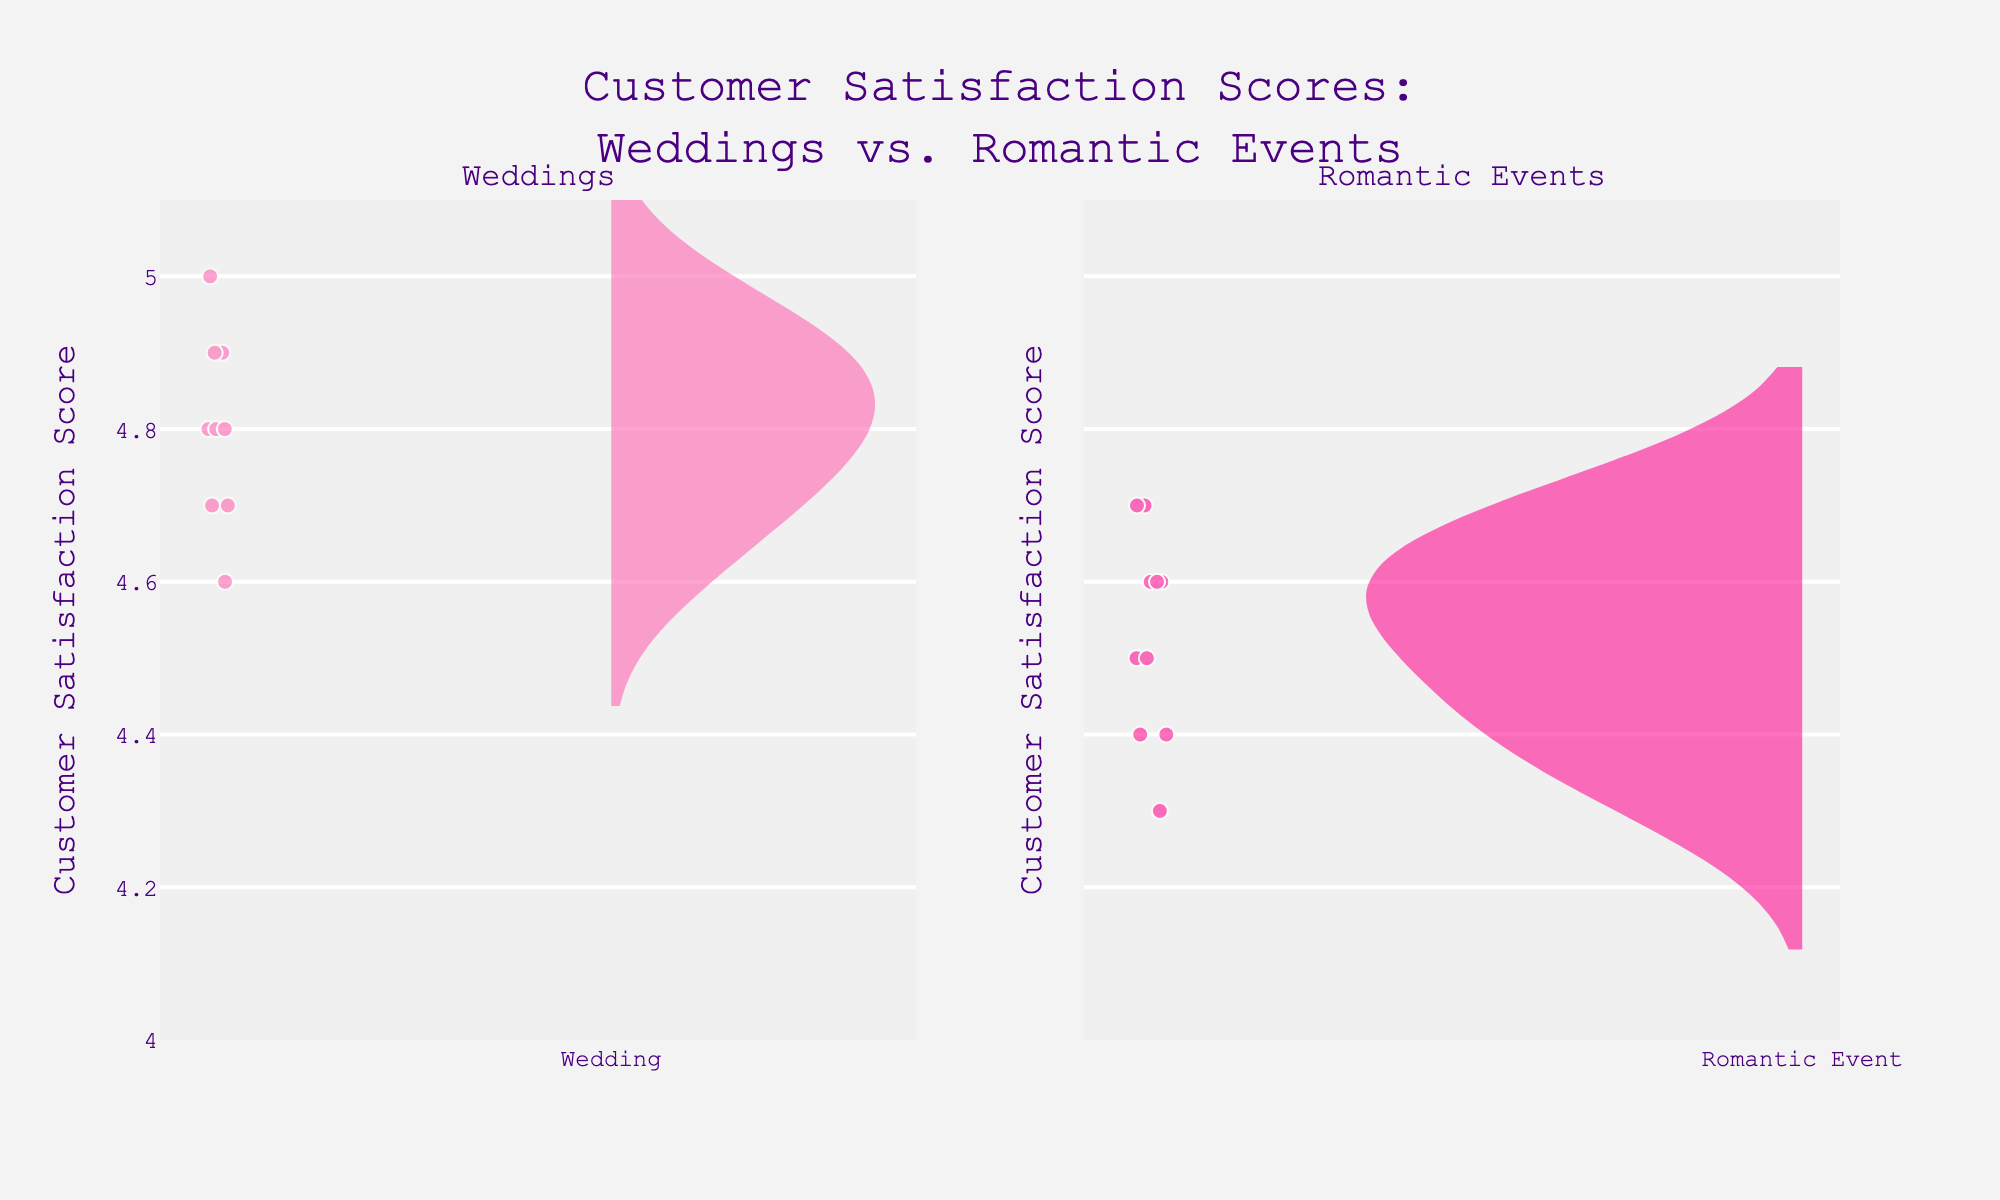Which event type has a higher mean customer satisfaction score? The mean line on the violin chart for weddings is at a higher score than that for romantic events, indicating that the mean score for weddings is higher.
Answer: Weddings What's the range of customer satisfaction scores for romantic events? The range is determined by the highest and lowest points on the violin chart for romantic events. The lowest score is 4.3 and the highest is 4.7.
Answer: 4.3 to 4.7 How do the distributions of customer satisfaction scores compare between weddings and romantic events? The violin chart for weddings shows a more concentrated and higher distribution of scores, while the chart for romantic events shows a broader range and slightly lower scores.
Answer: Weddings have a higher and more concentrated distribution; romantic events are broader and slightly lower How many customer satisfaction scores are plotted for weddings? You can count the individual data points represented on the violin chart; there are 10 points for weddings.
Answer: 10 On average, how does the customer satisfaction compare for weddings and romantic events? The average (mean) satisfaction score for weddings is higher, as indicated by the position of the mean line in the violin plots.
Answer: Weddings have a higher average satisfaction score What's the median satisfaction score for weddings? The median is the middle value when the data points are ordered. The violin plot for weddings shows a concentration around 4.8, indicating the median is 4.8.
Answer: 4.8 Are there any outliers in the customer satisfaction scores for romantic events? Outliers would appear as points far removed from the bulk of the data in the violin plot. The romantic events plot does not show any points far outside the main range.
Answer: No Do weddings or romantic events have more variability in customer satisfaction scores? Variability is indicated by the spread of the violin plot. Romantic events have a wider spread, indicating more variability compared to weddings.
Answer: Romantic events Which event type has the highest individual customer satisfaction score? The highest individual score can be determined by looking at the top of each violin plot; weddings have a score of 5.0.
Answer: Weddings By how much does the highest satisfaction score for weddings exceed the highest score for romantic events? The highest score for weddings is 5.0 and for romantic events is 4.7. The difference is 5.0 - 4.7.
Answer: 0.3 